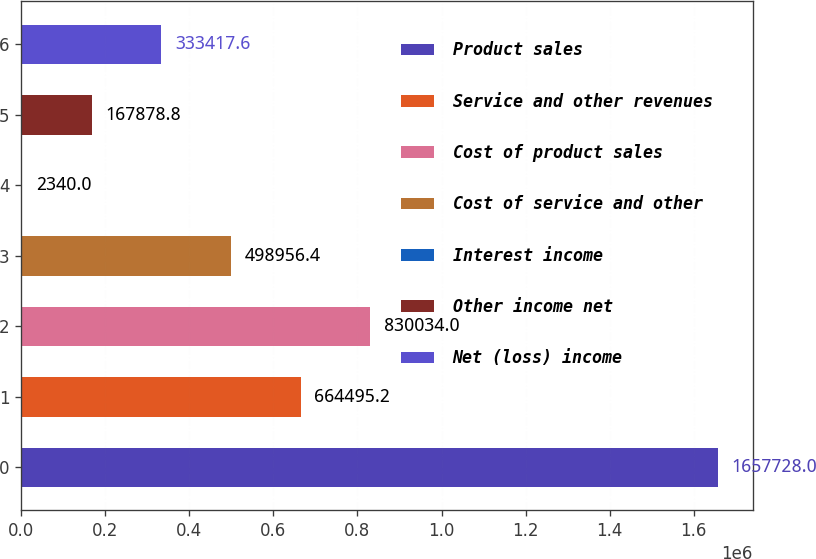<chart> <loc_0><loc_0><loc_500><loc_500><bar_chart><fcel>Product sales<fcel>Service and other revenues<fcel>Cost of product sales<fcel>Cost of service and other<fcel>Interest income<fcel>Other income net<fcel>Net (loss) income<nl><fcel>1.65773e+06<fcel>664495<fcel>830034<fcel>498956<fcel>2340<fcel>167879<fcel>333418<nl></chart> 